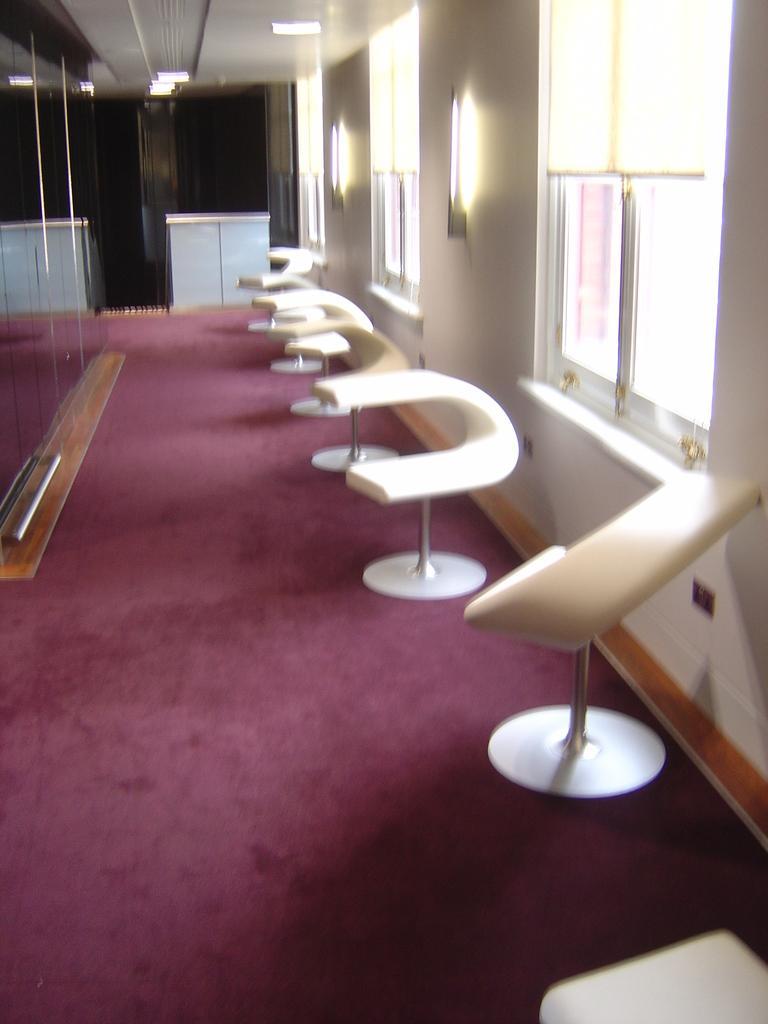Can you describe this image briefly? In the image there are few chairs in front of wall with windows and lights on it, there is a purple carpet on the floor with a table in the back and the ceiling is with lights, on the left side there is mirror on the wall. 